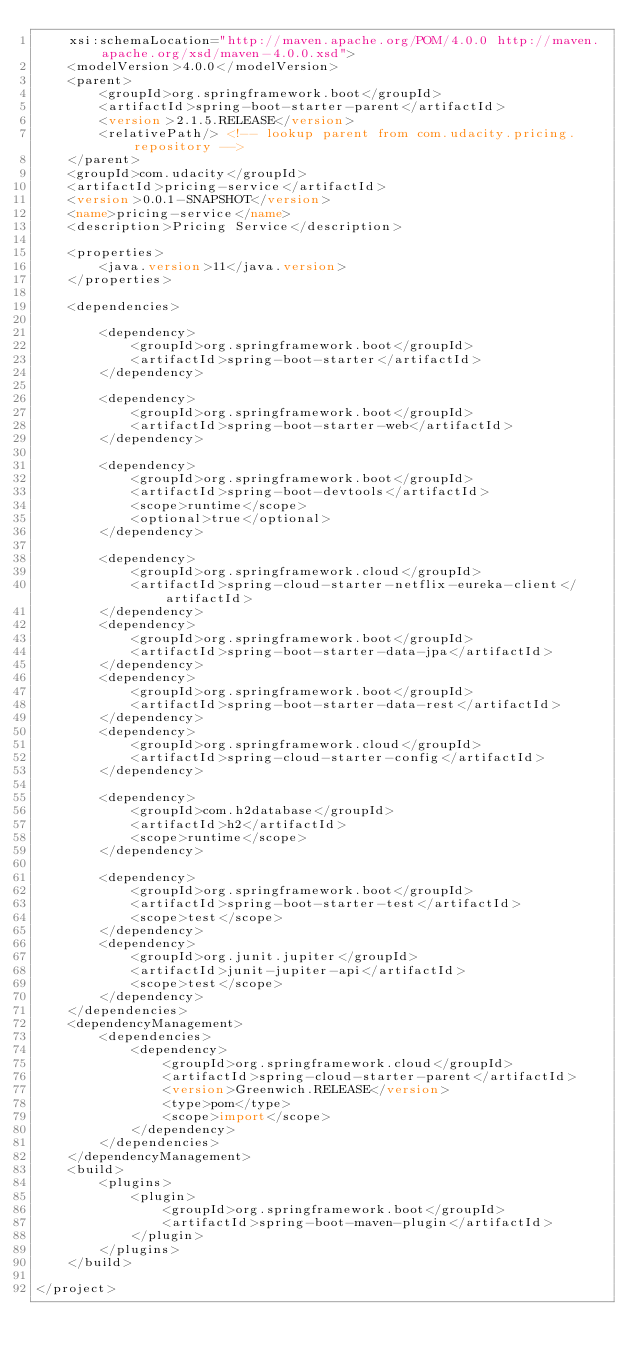<code> <loc_0><loc_0><loc_500><loc_500><_XML_>	xsi:schemaLocation="http://maven.apache.org/POM/4.0.0 http://maven.apache.org/xsd/maven-4.0.0.xsd">
	<modelVersion>4.0.0</modelVersion>
	<parent>
		<groupId>org.springframework.boot</groupId>
		<artifactId>spring-boot-starter-parent</artifactId>
		<version>2.1.5.RELEASE</version>
		<relativePath/> <!-- lookup parent from com.udacity.pricing.repository -->
	</parent>
	<groupId>com.udacity</groupId>
	<artifactId>pricing-service</artifactId>
	<version>0.0.1-SNAPSHOT</version>
	<name>pricing-service</name>
	<description>Pricing Service</description>

	<properties>
		<java.version>11</java.version>
	</properties>

	<dependencies>

		<dependency>
			<groupId>org.springframework.boot</groupId>
			<artifactId>spring-boot-starter</artifactId>
		</dependency>

		<dependency>
			<groupId>org.springframework.boot</groupId>
			<artifactId>spring-boot-starter-web</artifactId>
		</dependency>

		<dependency>
			<groupId>org.springframework.boot</groupId>
			<artifactId>spring-boot-devtools</artifactId>
			<scope>runtime</scope>
			<optional>true</optional>
		</dependency>

		<dependency>
			<groupId>org.springframework.cloud</groupId>
			<artifactId>spring-cloud-starter-netflix-eureka-client</artifactId>
		</dependency>
		<dependency>
			<groupId>org.springframework.boot</groupId>
			<artifactId>spring-boot-starter-data-jpa</artifactId>
		</dependency>
		<dependency>
			<groupId>org.springframework.boot</groupId>
			<artifactId>spring-boot-starter-data-rest</artifactId>
		</dependency>
		<dependency>
			<groupId>org.springframework.cloud</groupId>
			<artifactId>spring-cloud-starter-config</artifactId>
		</dependency>

		<dependency>
			<groupId>com.h2database</groupId>
			<artifactId>h2</artifactId>
			<scope>runtime</scope>
		</dependency>

		<dependency>
			<groupId>org.springframework.boot</groupId>
			<artifactId>spring-boot-starter-test</artifactId>
			<scope>test</scope>
		</dependency>
		<dependency>
			<groupId>org.junit.jupiter</groupId>
			<artifactId>junit-jupiter-api</artifactId>
			<scope>test</scope>
		</dependency>
	</dependencies>
	<dependencyManagement>
		<dependencies>
			<dependency>
				<groupId>org.springframework.cloud</groupId>
				<artifactId>spring-cloud-starter-parent</artifactId>
				<version>Greenwich.RELEASE</version>
				<type>pom</type>
				<scope>import</scope>
			</dependency>
		</dependencies>
	</dependencyManagement>
	<build>
		<plugins>
			<plugin>
				<groupId>org.springframework.boot</groupId>
				<artifactId>spring-boot-maven-plugin</artifactId>
			</plugin>
		</plugins>
	</build>

</project>
</code> 